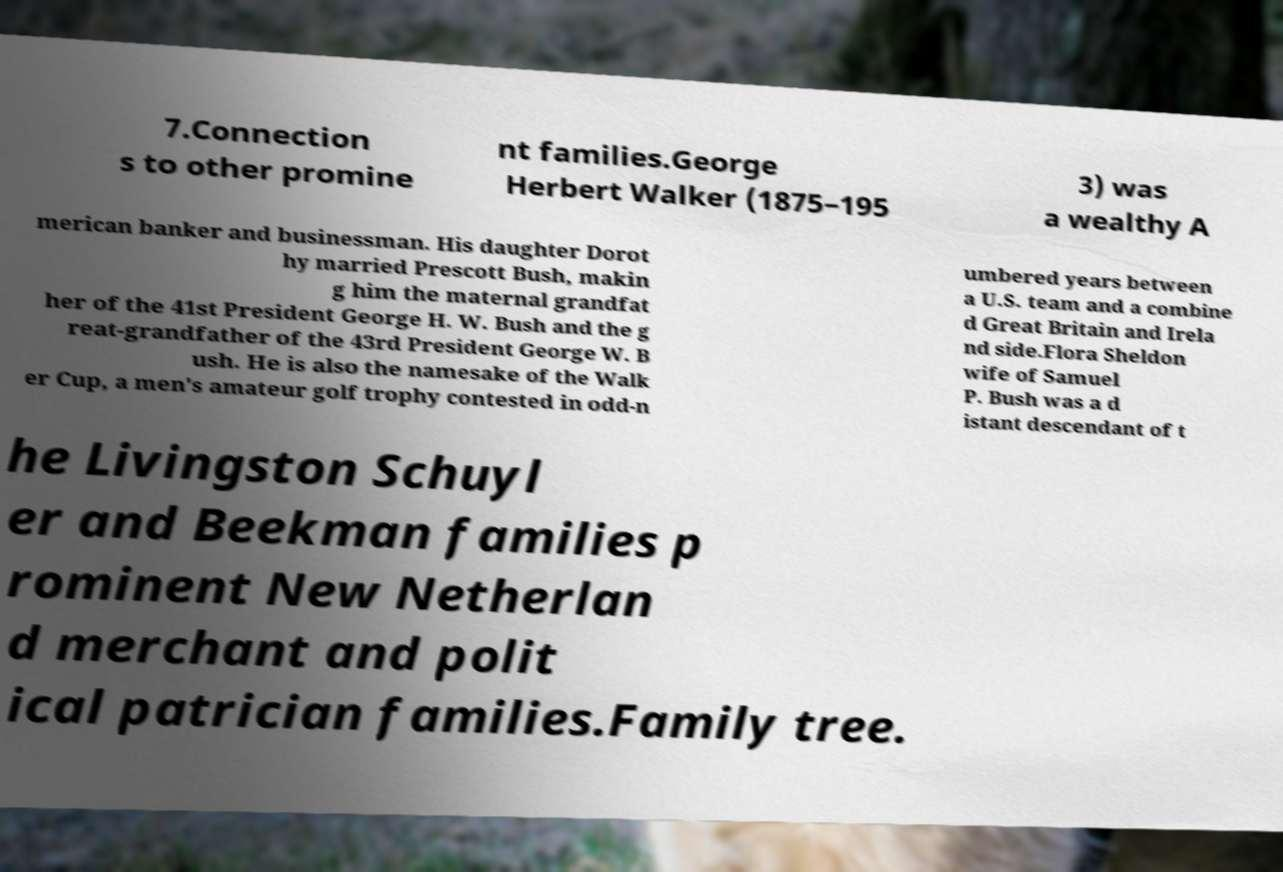There's text embedded in this image that I need extracted. Can you transcribe it verbatim? 7.Connection s to other promine nt families.George Herbert Walker (1875–195 3) was a wealthy A merican banker and businessman. His daughter Dorot hy married Prescott Bush, makin g him the maternal grandfat her of the 41st President George H. W. Bush and the g reat-grandfather of the 43rd President George W. B ush. He is also the namesake of the Walk er Cup, a men's amateur golf trophy contested in odd-n umbered years between a U.S. team and a combine d Great Britain and Irela nd side.Flora Sheldon wife of Samuel P. Bush was a d istant descendant of t he Livingston Schuyl er and Beekman families p rominent New Netherlan d merchant and polit ical patrician families.Family tree. 